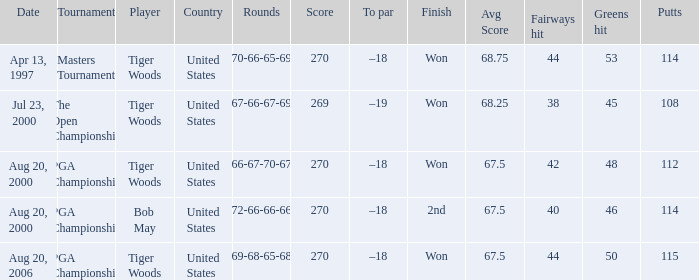What days did the rounds of 66-67-70-67 get registered? Aug 20, 2000. 